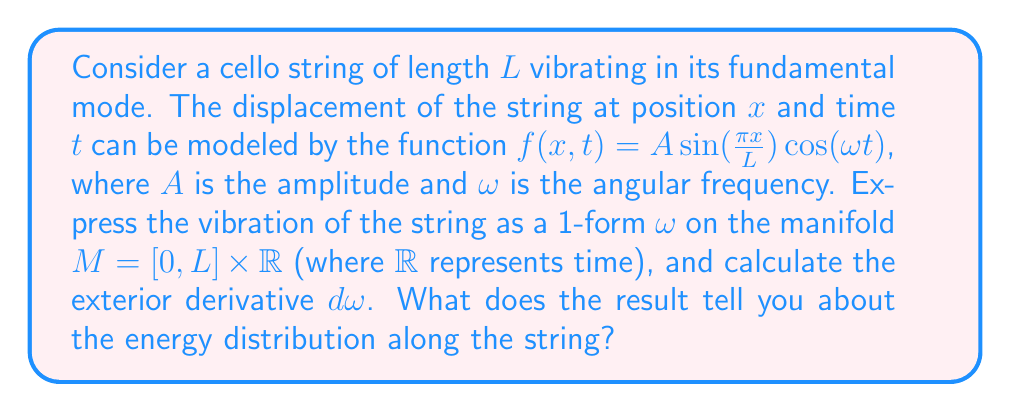Give your solution to this math problem. 1) First, we need to express the vibration as a 1-form. Given the displacement function:

   $f(x,t) = A \sin(\frac{\pi x}{L}) \cos(\omega t)$

   We can write the 1-form as:

   $\omega = f(x,t) dx = A \sin(\frac{\pi x}{L}) \cos(\omega t) dx$

2) To calculate the exterior derivative $d\omega$, we need to differentiate with respect to both $x$ and $t$:

   $d\omega = \frac{\partial f}{\partial x} dx \wedge dx + \frac{\partial f}{\partial t} dt \wedge dx$

3) Calculating the partial derivatives:

   $\frac{\partial f}{\partial x} = A \frac{\pi}{L} \cos(\frac{\pi x}{L}) \cos(\omega t)$
   
   $\frac{\partial f}{\partial t} = -A \omega \sin(\frac{\pi x}{L}) \sin(\omega t)$

4) Substituting these back into the expression for $d\omega$:

   $d\omega = A \frac{\pi}{L} \cos(\frac{\pi x}{L}) \cos(\omega t) dx \wedge dx - A \omega \sin(\frac{\pi x}{L}) \sin(\omega t) dt \wedge dx$

5) Note that $dx \wedge dx = 0$, so the first term vanishes:

   $d\omega = -A \omega \sin(\frac{\pi x}{L}) \sin(\omega t) dt \wedge dx$

6) The result shows that the exterior derivative $d\omega$ is non-zero and varies with both position and time. This indicates that the energy is not uniformly distributed along the string.

7) The $\sin(\frac{\pi x}{L})$ term in $d\omega$ shows that the energy distribution follows the same spatial pattern as the displacement, with maximum energy at the center of the string $(x = L/2)$ and zero energy at the ends $(x = 0, L)$.

8) The $\sin(\omega t)$ term indicates that the energy oscillates in time, reaching its maximum when the string is at its maximum velocity (when displacement is zero) and minimum when the string is at its maximum displacement.
Answer: $d\omega = -A \omega \sin(\frac{\pi x}{L}) \sin(\omega t) dt \wedge dx$, indicating non-uniform energy distribution along the string, with maximum at the center and oscillating in time. 